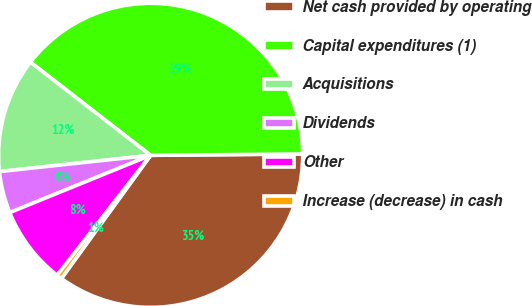Convert chart. <chart><loc_0><loc_0><loc_500><loc_500><pie_chart><fcel>Net cash provided by operating<fcel>Capital expenditures (1)<fcel>Acquisitions<fcel>Dividends<fcel>Other<fcel>Increase (decrease) in cash<nl><fcel>35.12%<fcel>39.36%<fcel>12.2%<fcel>4.44%<fcel>8.32%<fcel>0.56%<nl></chart> 